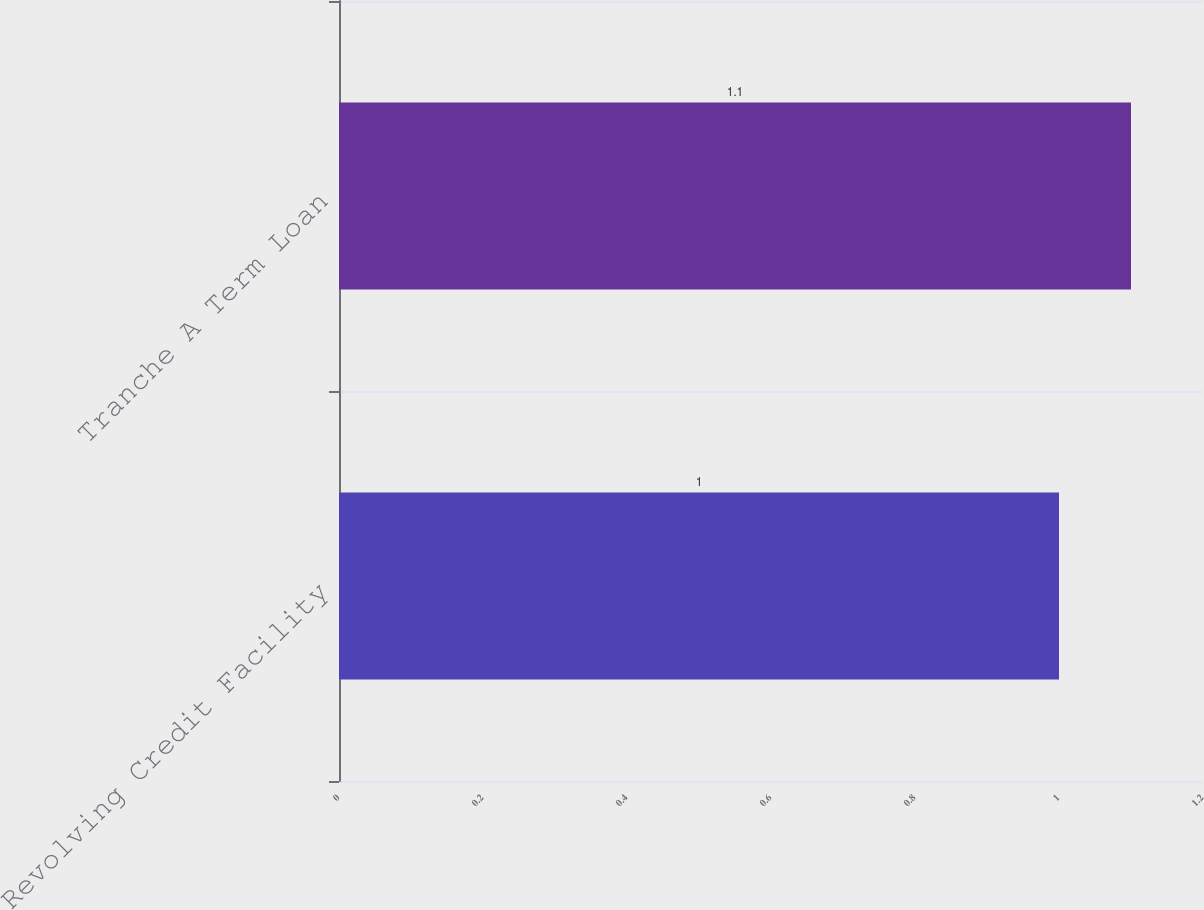<chart> <loc_0><loc_0><loc_500><loc_500><bar_chart><fcel>Revolving Credit Facility<fcel>Tranche A Term Loan<nl><fcel>1<fcel>1.1<nl></chart> 